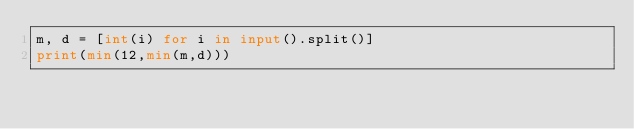Convert code to text. <code><loc_0><loc_0><loc_500><loc_500><_Python_>m, d = [int(i) for i in input().split()]
print(min(12,min(m,d)))</code> 